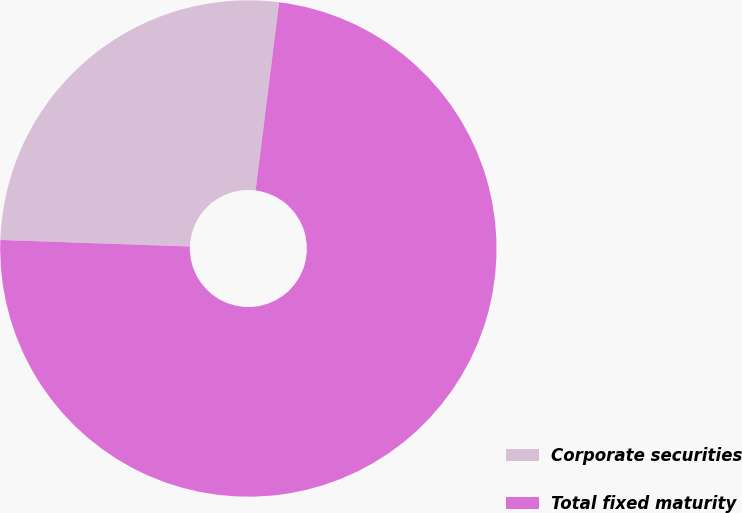<chart> <loc_0><loc_0><loc_500><loc_500><pie_chart><fcel>Corporate securities<fcel>Total fixed maturity<nl><fcel>26.43%<fcel>73.57%<nl></chart> 